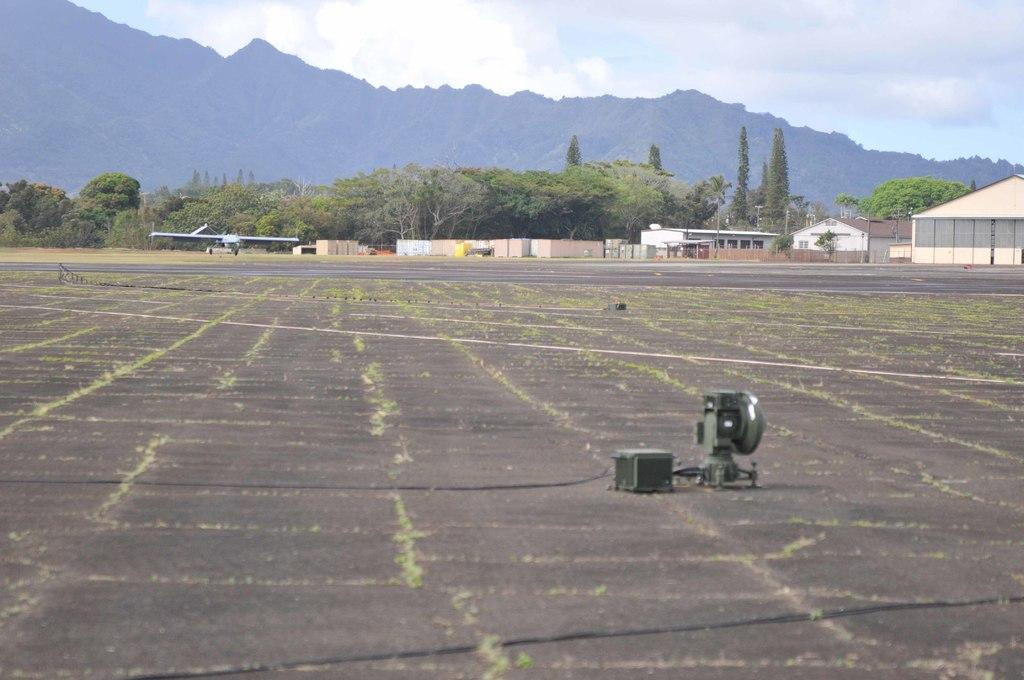What type of structures are visible in the image? There are houses in the image. What natural elements can be seen in the image? There are trees and hills in the image. What is the weather like in the image? The sky is cloudy in the image. What man-made object is on the ground in the image? There is a machine on the ground in the image. What type of vehicle can be seen in the background of the image? There appears to be a jet plane in the background of the image. What type of advertisement is visible on the trees in the image? There is no advertisement present on the trees in the image. How many credits are required to use the machine in the image? There is no mention of credits or any need for them to use the machine in the image. 